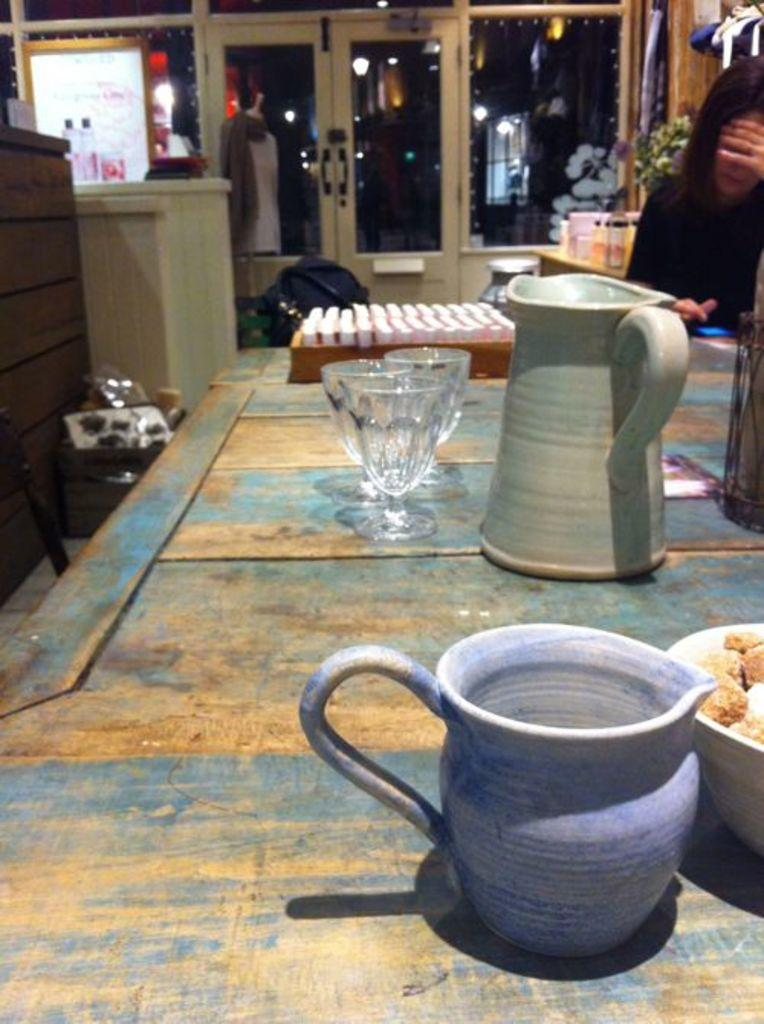What type of container is visible in the image? There is a jar and a jug in the image. What other type of container is present in the image? There is also a glass in the image. What is inside the glass? The image does not specify what is inside the glass. What object is present in the image? The object is not described in the facts provided. What type of food can be seen in the image? There is a bowl of food in the image. What furniture item is visible in the background of the image? There is a chair in the background of the image. What architectural feature is visible in the background of the image? There is a door in the background of the image. What other object is visible in the background of the image? There is a bottle in the background of the image. What type of vegetation is present in the background of the image? There is a plant in the background of the image. What else can be seen in the background of the image? There is a person in the background of the image. How does the glass emit steam in the image? The image does not show any steam coming from the glass. 